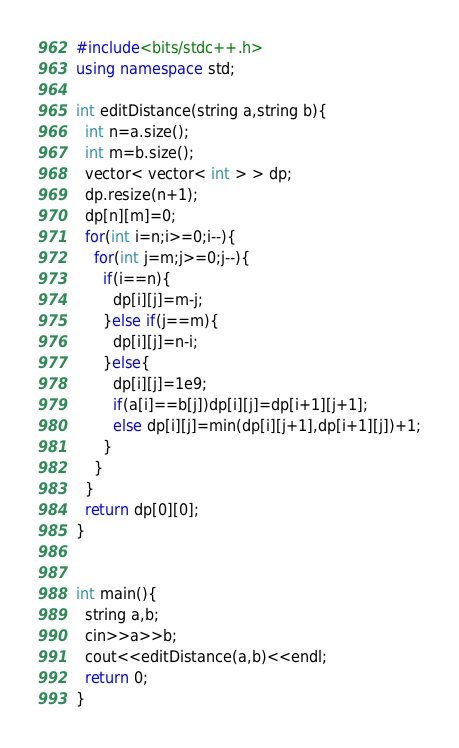<code> <loc_0><loc_0><loc_500><loc_500><_C++_>#include<bits/stdc++.h>
using namespace std;

int editDistance(string a,string b){
  int n=a.size();
  int m=b.size();
  vector< vector< int > > dp;
  dp.resize(n+1);
  dp[n][m]=0;
  for(int i=n;i>=0;i--){
    for(int j=m;j>=0;j--){
      if(i==n){
        dp[i][j]=m-j;
      }else if(j==m){
        dp[i][j]=n-i;
      }else{
        dp[i][j]=1e9;
        if(a[i]==b[j])dp[i][j]=dp[i+1][j+1];
        else dp[i][j]=min(dp[i][j+1],dp[i+1][j])+1;
      }
    }
  }
  return dp[0][0];
}


int main(){
  string a,b;
  cin>>a>>b;
  cout<<editDistance(a,b)<<endl;
  return 0;
}</code> 